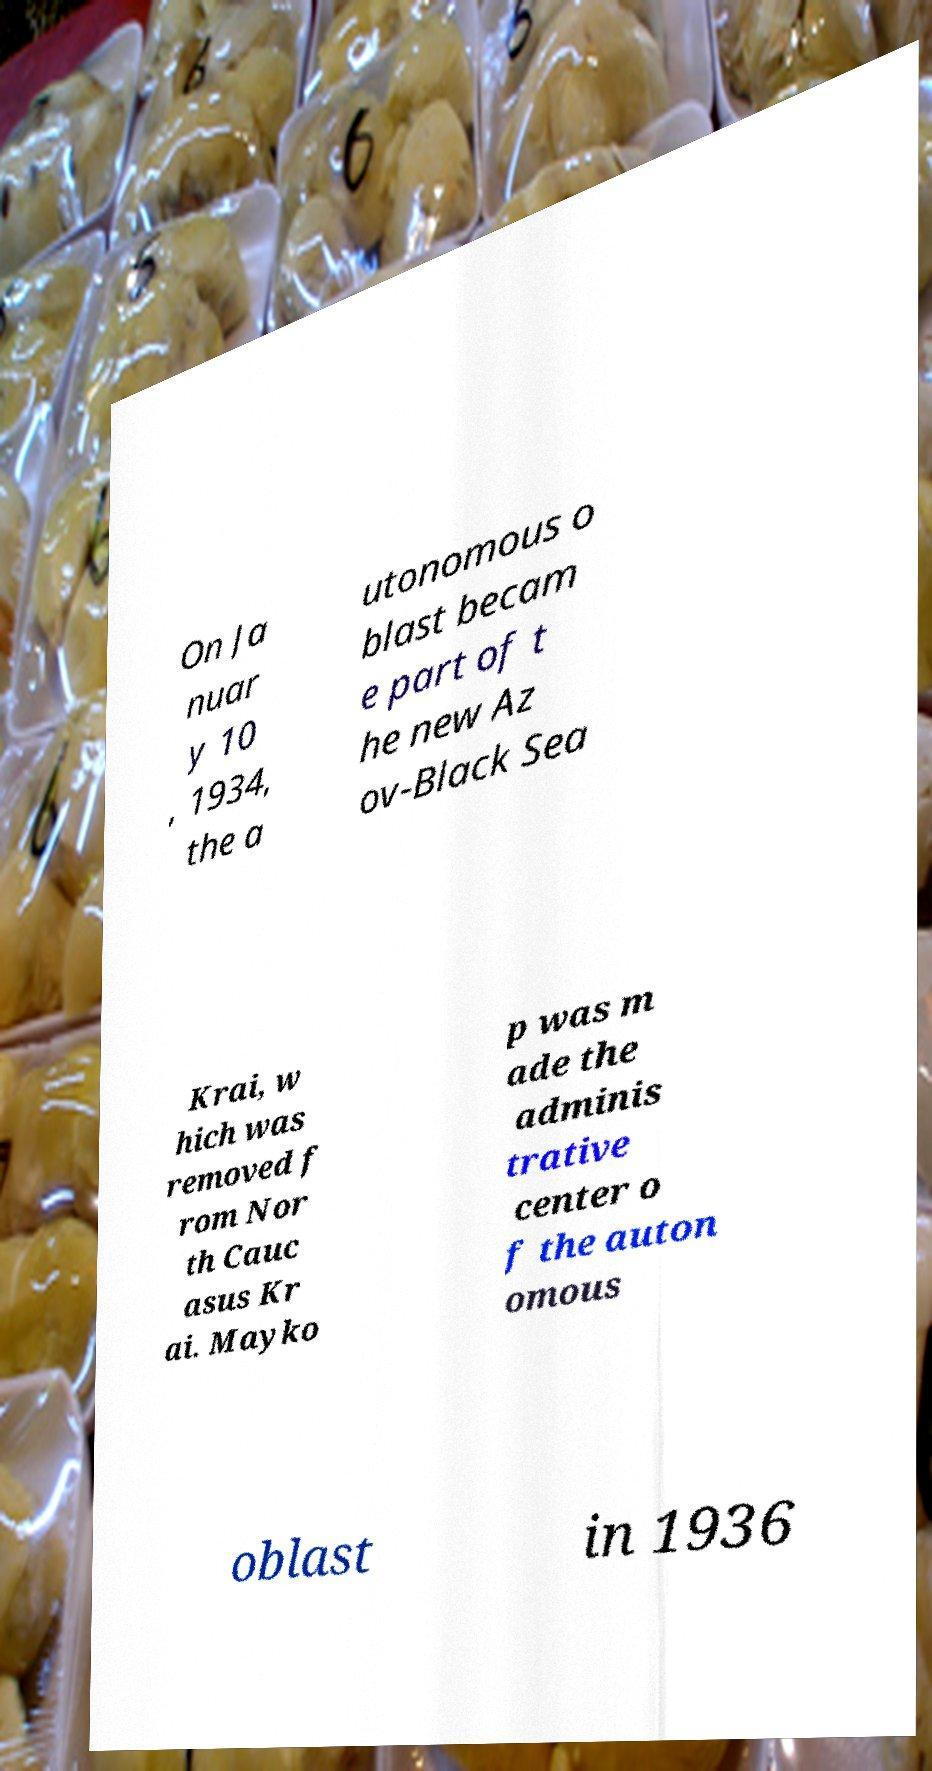Can you accurately transcribe the text from the provided image for me? On Ja nuar y 10 , 1934, the a utonomous o blast becam e part of t he new Az ov-Black Sea Krai, w hich was removed f rom Nor th Cauc asus Kr ai. Mayko p was m ade the adminis trative center o f the auton omous oblast in 1936 